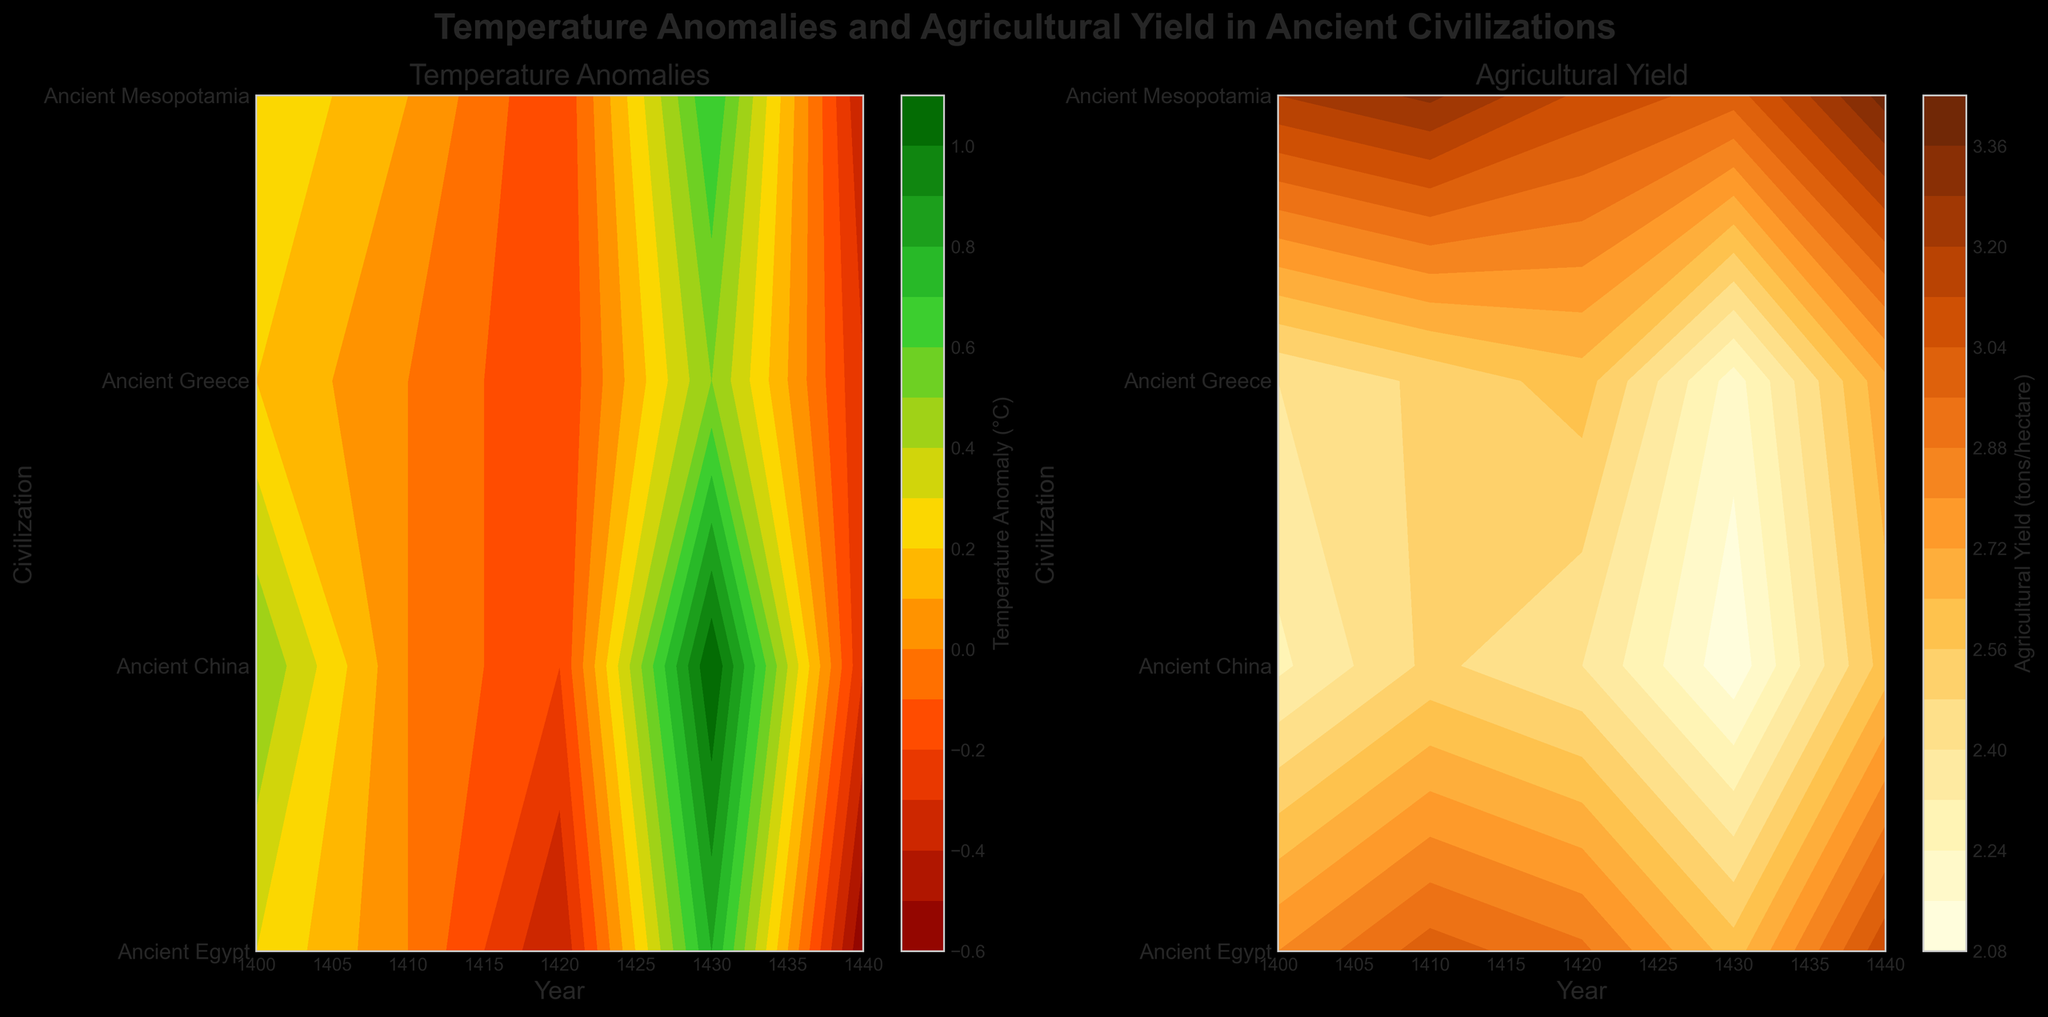How does the temperature anomaly trend change over the years for Ancient Egypt? By observing the contours of the 'Temperature Anomalies' plot, we can see Ancient Egypt's temperature anomaly changes its color over the years. In the 1400s it starts higher, dips around 1410 and 1420, peaks at 1430, and dips again at 1440.
Answer: It fluctuates with a peak around 1430 Which civilization had the highest agricultural yield in 1420? Look at the 'Agricultural Yield' plot and identify the contour levels for the year 1420. Compare the levels among different civilizations. Ancient Mesopotamia has the highest yield indicated by the darkest color.
Answer: Ancient Mesopotamia What is the overall trend of agricultural yield for Ancient Greece between 1400 and 1440? In the 'Agricultural Yield' plot, Ancient Greece has yield values changing with contours. Initially, it appears moderate, dips slightly around 1430, and improves slightly by 1440.
Answer: Moderate drop around 1430, slight improvement by 1440 How does the temperature anomaly for Ancient China in 1440 compare to 1400? Compare the colors indicating temperature anomaly for Ancient China in 1440 and 1400 in the 'Temperature Anomalies' plot. The contour color in 1440 is cooler than in 1400, showing a negative anomaly.
Answer: It is lower in 1440 Which civilization experienced the most significant temperature anomaly in 1430? Observe the darkest or most intense contour color indicating the highest anomaly in the 'Temperature Anomalies' plot for 1430. Ancient Egypt shows the most significant anomaly.
Answer: Ancient Egypt Compare the agricultural yield trend of Ancient Mesopotamia with that of Ancient Greece across the years. Look at the contour shifts across years for both Mesopotamia and Greece in the 'Agricultural Yield' plot. Mesopotamia's yield appears largely stable or improving slightly, whereas Greece shows more variations and slight dips around 1430.
Answer: Mesopotamia is more stable, Greece more variable What is the title of this figure? The title can be read from the top of the figure and states the main focus of both subplots.
Answer: Temperature Anomalies and Agricultural Yield in Ancient Civilizations How many civilizations are compared in the plots? The number of y-ticks on both subplots helps to count the unique civilizations.
Answer: Four Which year shows the least temperature anomaly for Ancient Greece? Look for the lightest contour color in the 'Temperature Anomalies' plot for Ancient Greece. The year 1440 has the lightest color, signifying the least anomaly.
Answer: 1440 